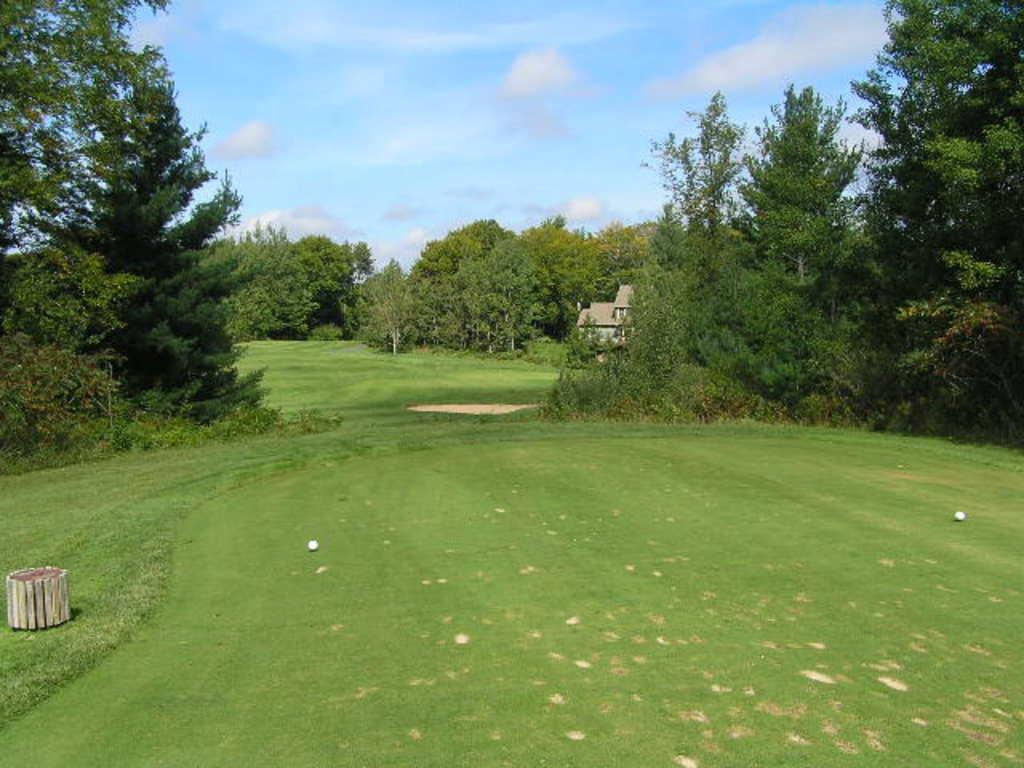What type of vegetation is visible in the image? There are many trees in the image. What objects can be seen on the ground in the image? There are two balls in the image. Where is the object located in the image? There is an object on the left side of the image. What type of structure is present in the image? There is a house in the image. What is visible in the sky in the image? The sky is visible at the top of the image, with clouds. What type of ground cover is present at the bottom of the image? Grass is present at the bottom of the image. What type of pancake is being used to fix the wrench in the image? There is no pancake or wrench present in the image. How does the wind blow the trees in the image? The image does not depict any wind blowing the trees; the trees are stationary. 